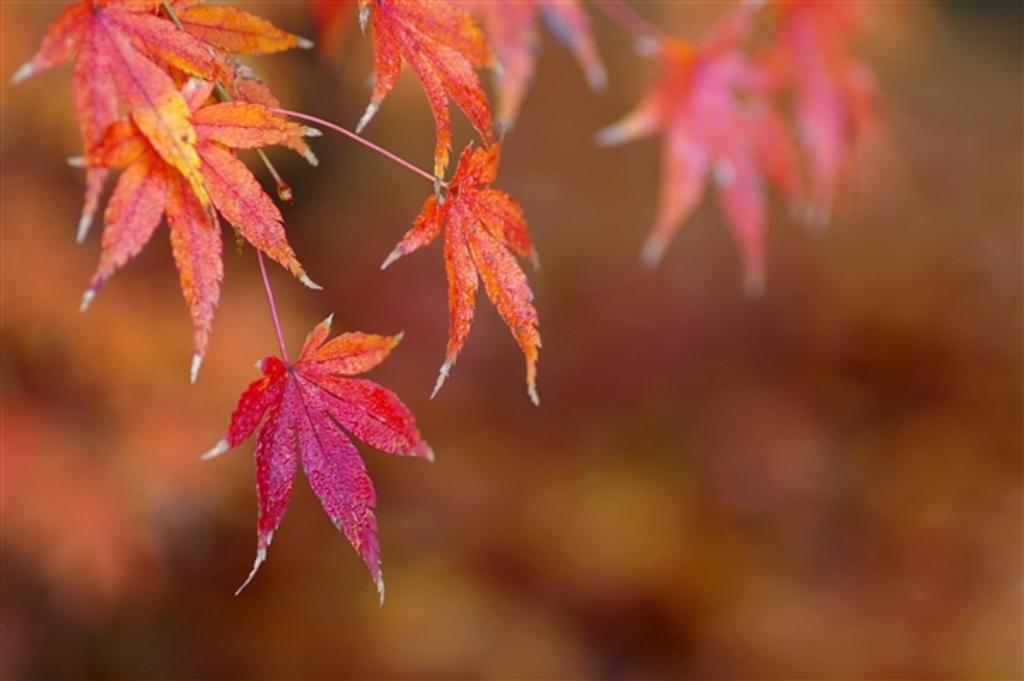What type of leaves are featured in the image? There are maple leaves in the image. What colors can be seen among the maple leaves? Some of the maple leaves are dark pink in color, while others are orange. Are there any other leaves visible in the image? Yes, there are other leaves visible in the background, but they are not clearly visible. Can you tell me how many ducks are swimming in the pond in the image? There is no pond or duck present in the image; it features maple leaves. What type of fruit is being eaten by the child during recess in the image? There is no child or fruit present in the image; it features maple leaves. 